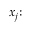Convert formula to latex. <formula><loc_0><loc_0><loc_500><loc_500>x _ { j } { \colon }</formula> 